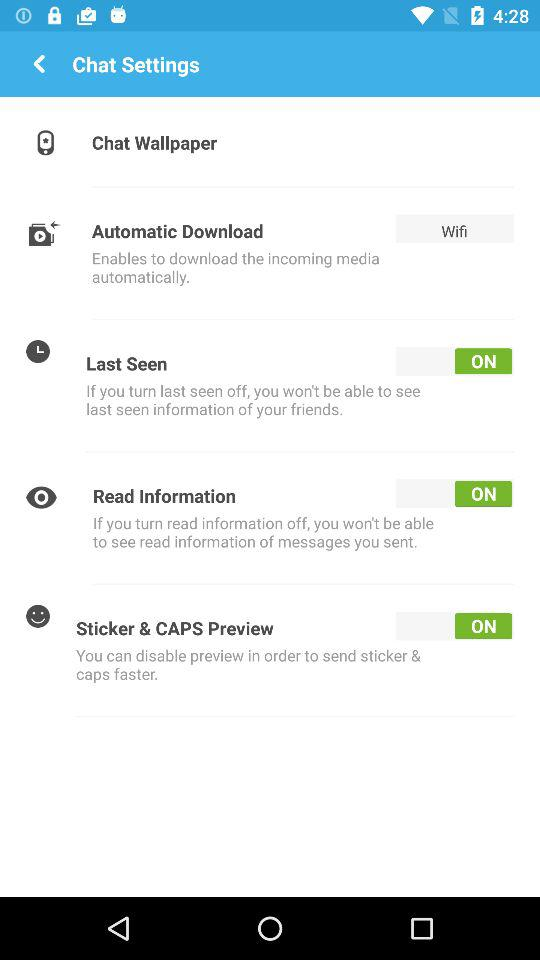Which option is selected in the automatic download setting? The selected option is "Wifi". 